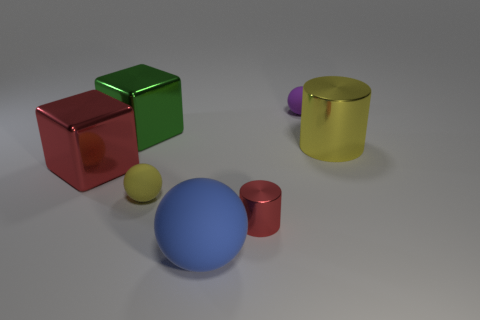Add 3 red metal cylinders. How many objects exist? 10 Subtract all cylinders. How many objects are left? 5 Subtract 0 blue cubes. How many objects are left? 7 Subtract all blocks. Subtract all purple balls. How many objects are left? 4 Add 7 big red things. How many big red things are left? 8 Add 1 cyan metallic cylinders. How many cyan metallic cylinders exist? 1 